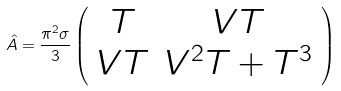<formula> <loc_0><loc_0><loc_500><loc_500>\hat { A } = \frac { \pi ^ { 2 } \sigma } { 3 } \left ( \begin{array} { c c } T & V T \\ V T & V ^ { 2 } T + T ^ { 3 } \end{array} \right )</formula> 